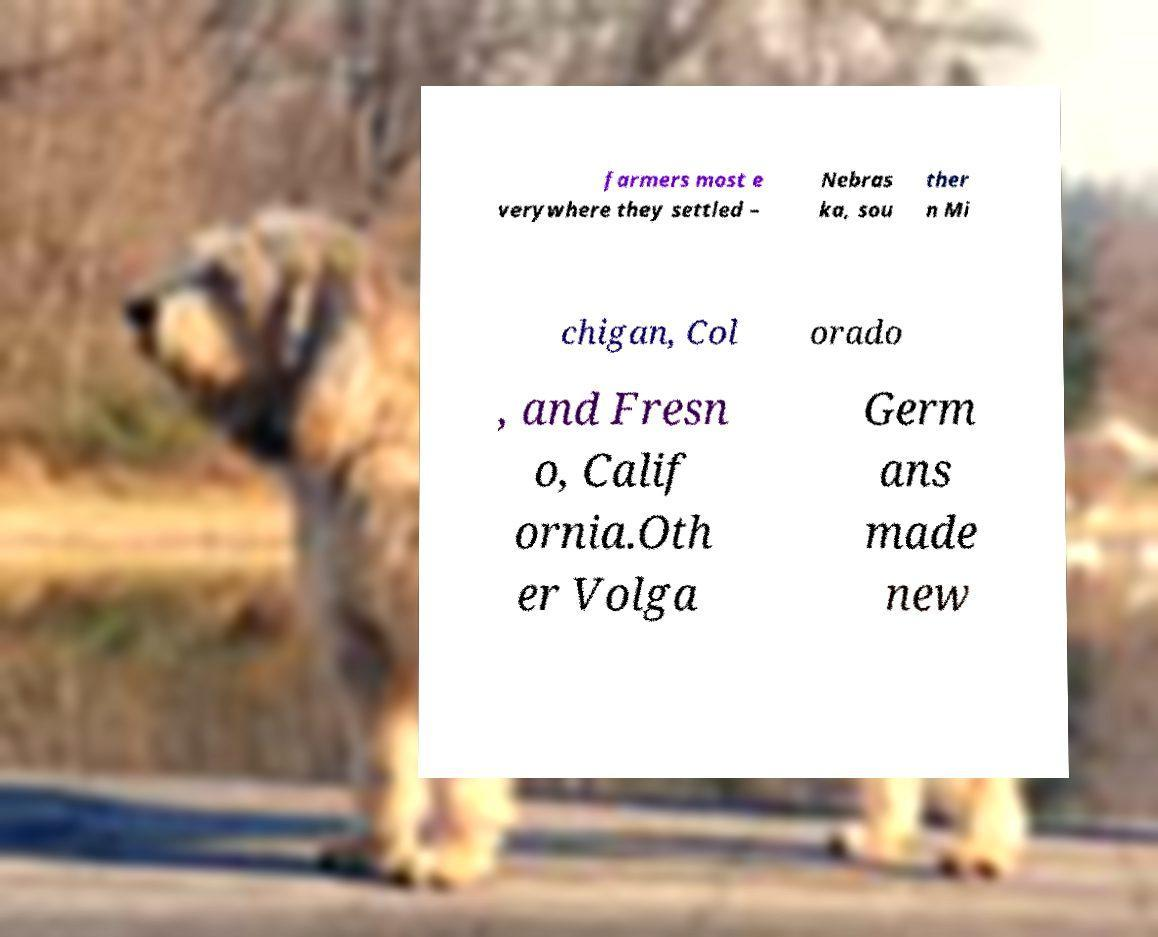Can you accurately transcribe the text from the provided image for me? farmers most e verywhere they settled – Nebras ka, sou ther n Mi chigan, Col orado , and Fresn o, Calif ornia.Oth er Volga Germ ans made new 